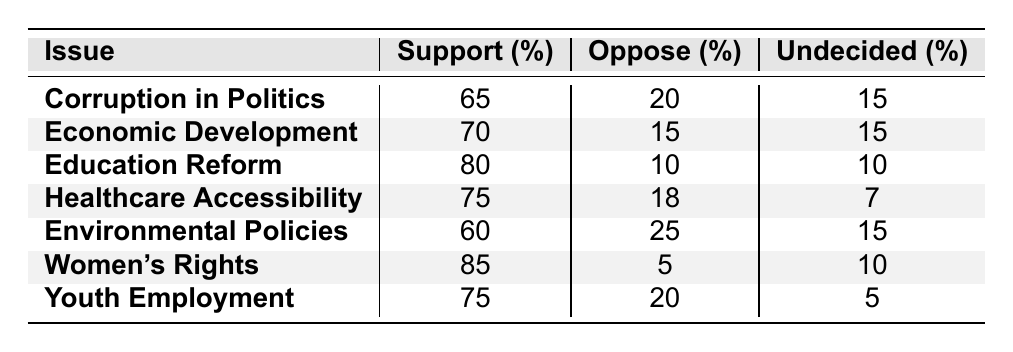What percentage of respondents support Women's Rights? The table indicates that 85% of respondents support Women's Rights, as directly stated under the "Support (%)" column for that issue.
Answer: 85% Which issue has the highest opposition percentage? By comparing the "Oppose (%)" values across all issues, Environmental Policies has the highest opposition percentage at 25%.
Answer: 25% What is the support percentage for Education Reform? The table shows that 80% of respondents support Education Reform, as indicated in the corresponding "Support (%)" column.
Answer: 80% What is the percentage of respondents who are undecided about Economic Development? The "Undecided (%)" value for Economic Development is listed as 15% in the table.
Answer: 15% If you add the support percentages of Corruption in Politics and Healthcare Accessibility, what do you get? The support percentages for Corruption in Politics (65%) and Healthcare Accessibility (75%) can be summed: 65 + 75 = 140.
Answer: 140 What percentage of respondents oppose Education Reform compared to Environmental Policies? Education Reform has 10% opposition, and Environmental Policies has 25%. The latter is higher, indicating more opposition to Environmental Policies.
Answer: Higher for Environmental Policies Is there a higher support for Youth Employment or Healthcare Accessibility? Youth Employment has a support percentage of 75%, while Healthcare Accessibility has 75% too. Therefore, support is equal for both issues.
Answer: Equal What is the average undecided percentage across all issues? To find the average, sum the undecided percentages: (15 + 15 + 10 + 7 + 15 + 10 + 5) = 77. Then divide by the number of issues (7): 77/7 = 11.
Answer: 11 How many issues have a support percentage of 70% or higher? The table shows that 5 issues (Economic Development, Education Reform, Healthcare Accessibility, Women's Rights, Youth Employment) have a support percentage of 70% or higher.
Answer: 5 Which issue has the lowest support percentage among the listed issues? By comparing all the "Support (%)" values in the table, Environmental Policies has the lowest support percentage at 60%.
Answer: 60% Do more respondents support Economic Development or oppose it? The support for Economic Development is 70%, while the opposition is 15%. Since 70% is greater than 15%, more respondents support it.
Answer: Support is greater 